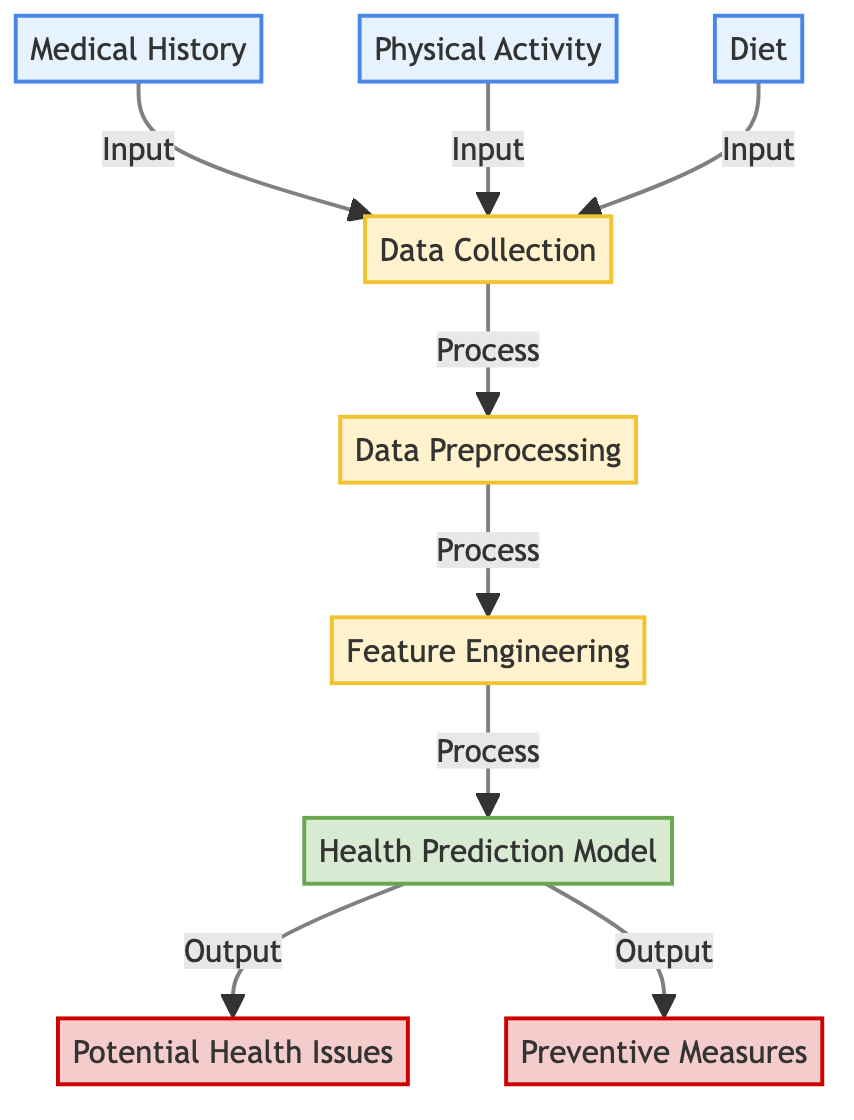What are the three types of data inputs in this diagram? The three types of data inputs are depicted at the top of the diagram: Medical History, Physical Activity, and Diet. These inputs are the starting points for the data collection process.
Answer: Medical History, Physical Activity, Diet What is the first process after data collection? The diagram shows an arrow leading from Data Collection to Data Preprocessing, indicating that Data Preprocessing is the first process that occurs after Data Collection.
Answer: Data Preprocessing How many output nodes are shown in the diagram? The diagram includes two output nodes: Potential Health Issues and Preventive Measures. Therefore, there are a total of two outputs.
Answer: 2 What model is used to predict health issues in the diagram? The diagram explicitly labels a node called "Health Prediction Model," which is the model used to predict potential health issues.
Answer: Health Prediction Model Which node comes directly before the Health Prediction Model? The diagram indicates that Feature Engineering comes directly before the Health Prediction Model, as indicated by the arrow connecting them.
Answer: Feature Engineering What is the relationship between potential health issues and preventive measures? The diagram shows that both Potential Health Issues and Preventive Measures are outputs of the Health Prediction Model, indicating that they are related in the context of predictions made by the model.
Answer: Outputs of the Health Prediction Model How many nodes are involved in the data preprocessing stage? The data preprocessing stage consists of one node, simply labeled as "Data Preprocessing," making it the only node in this process area.
Answer: 1 What type of process follows data collection? The diagram categorizes the processes following data collection as processes represented in yellow. The first such process is labeled "Data Preprocessing," which follows data collection.
Answer: Data Preprocessing 